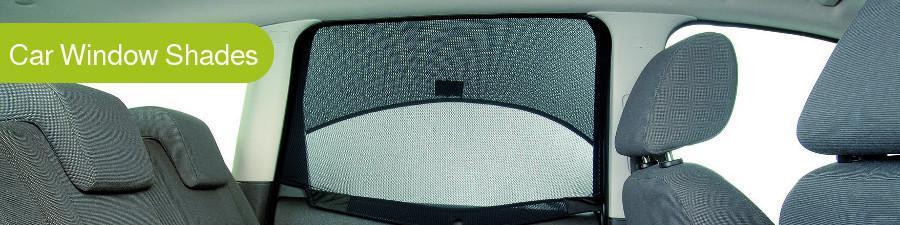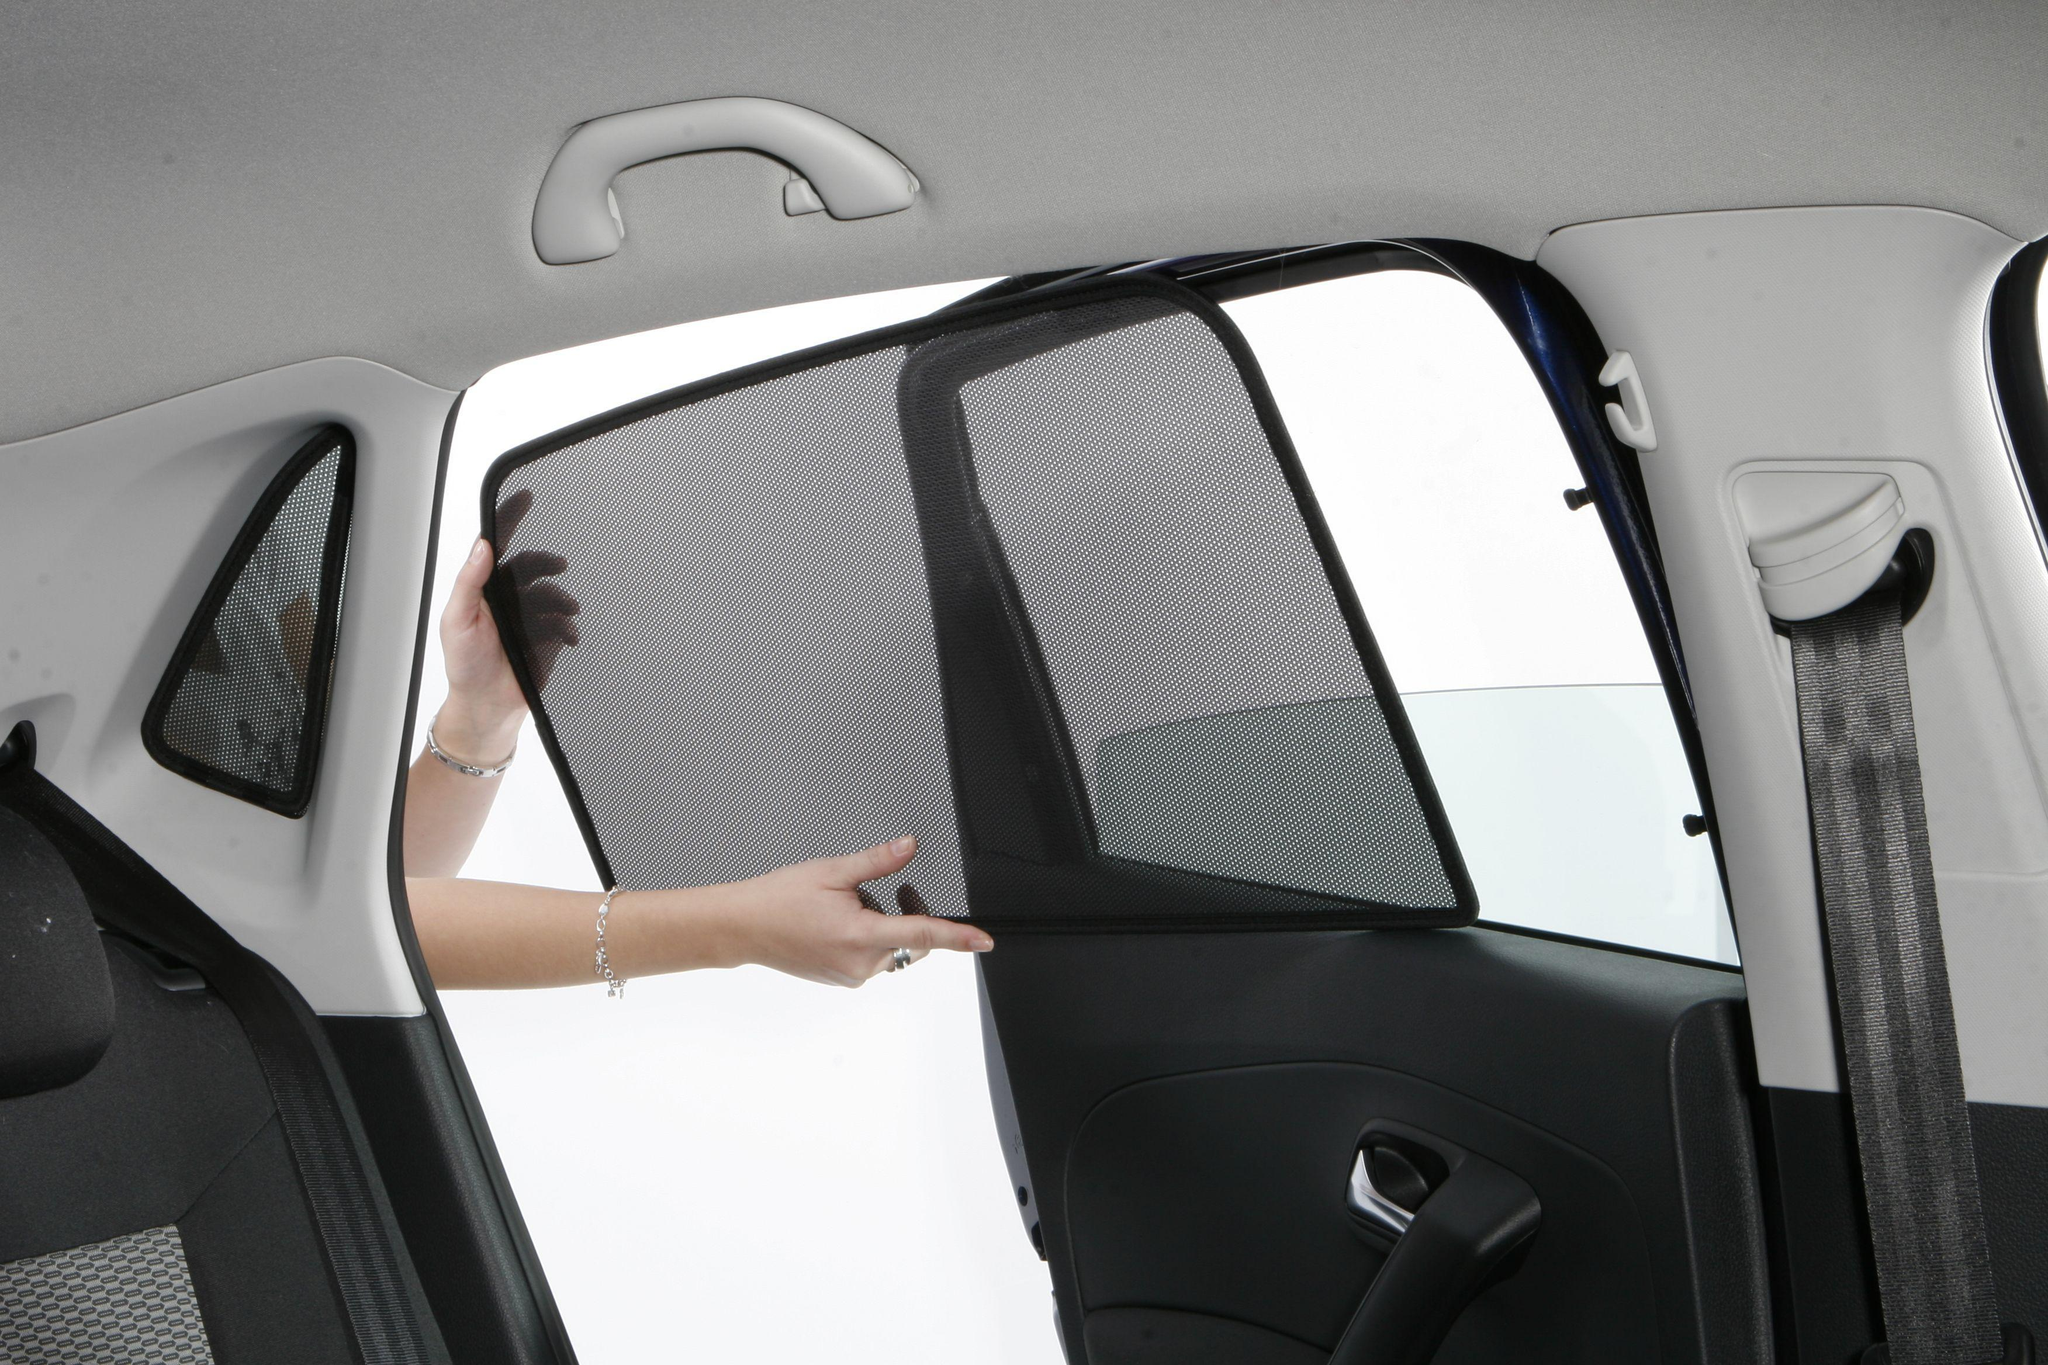The first image is the image on the left, the second image is the image on the right. For the images shown, is this caption "The car door is ajar in one of the images." true? Answer yes or no. Yes. 